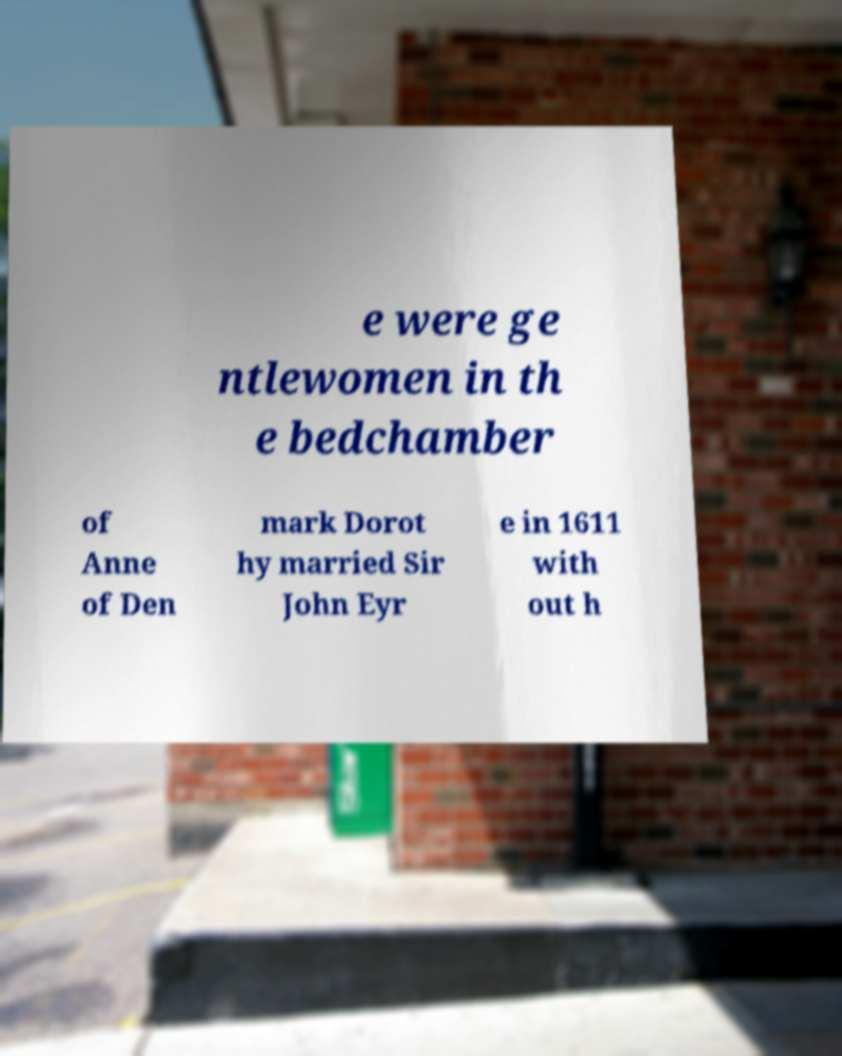Can you read and provide the text displayed in the image?This photo seems to have some interesting text. Can you extract and type it out for me? e were ge ntlewomen in th e bedchamber of Anne of Den mark Dorot hy married Sir John Eyr e in 1611 with out h 